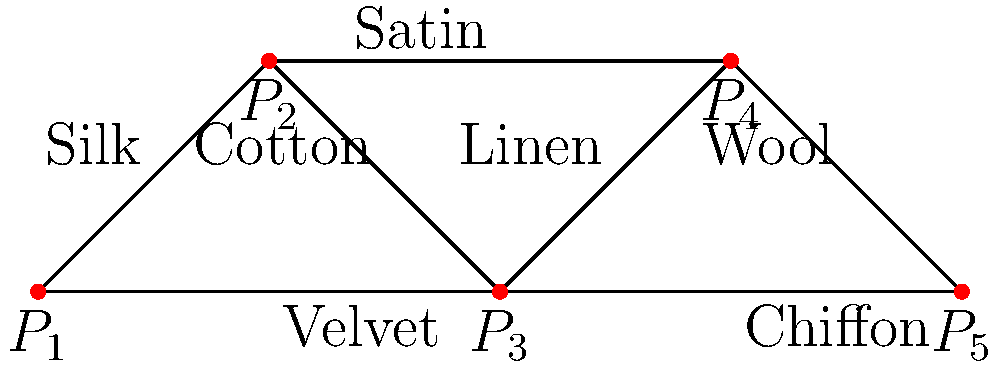In a period-inspired costume design project, different fabric patterns are represented as nodes in a graph, where edges indicate compatible fabric combinations. Given the graph above, where nodes $P_1$ to $P_5$ represent different pattern pieces and edges represent fabric types connecting them, what is the minimum number of fabric types needed to create a path from $P_1$ to $P_5$ that visits each node exactly once? To solve this problem, we need to find a Hamiltonian path from $P_1$ to $P_5$ that uses the minimum number of fabric types. Let's approach this step-by-step:

1. Identify all possible paths from $P_1$ to $P_5$ that visit each node exactly once:
   - $P_1 \rightarrow P_2 \rightarrow P_3 \rightarrow P_4 \rightarrow P_5$
   - $P_1 \rightarrow P_3 \rightarrow P_2 \rightarrow P_4 \rightarrow P_5$
   - $P_1 \rightarrow P_3 \rightarrow P_4 \rightarrow P_2 \rightarrow P_5$

2. Analyze each path for the number of fabric types used:

   Path 1: $P_1 \rightarrow P_2 \rightarrow P_3 \rightarrow P_4 \rightarrow P_5$
   - Silk, Cotton, Linen, Wool
   - 4 fabric types

   Path 2: $P_1 \rightarrow P_3 \rightarrow P_2 \rightarrow P_4 \rightarrow P_5$
   - Velvet, Cotton, Satin, Wool
   - 4 fabric types

   Path 3: $P_1 \rightarrow P_3 \rightarrow P_4 \rightarrow P_2 \rightarrow P_5$
   - Velvet, Linen, Satin, Chiffon
   - 4 fabric types

3. Determine the minimum number of fabric types:
   All paths require 4 different fabric types, so the minimum number is 4.

Therefore, the minimum number of fabric types needed to create a path from $P_1$ to $P_5$ that visits each node exactly once is 4.
Answer: 4 